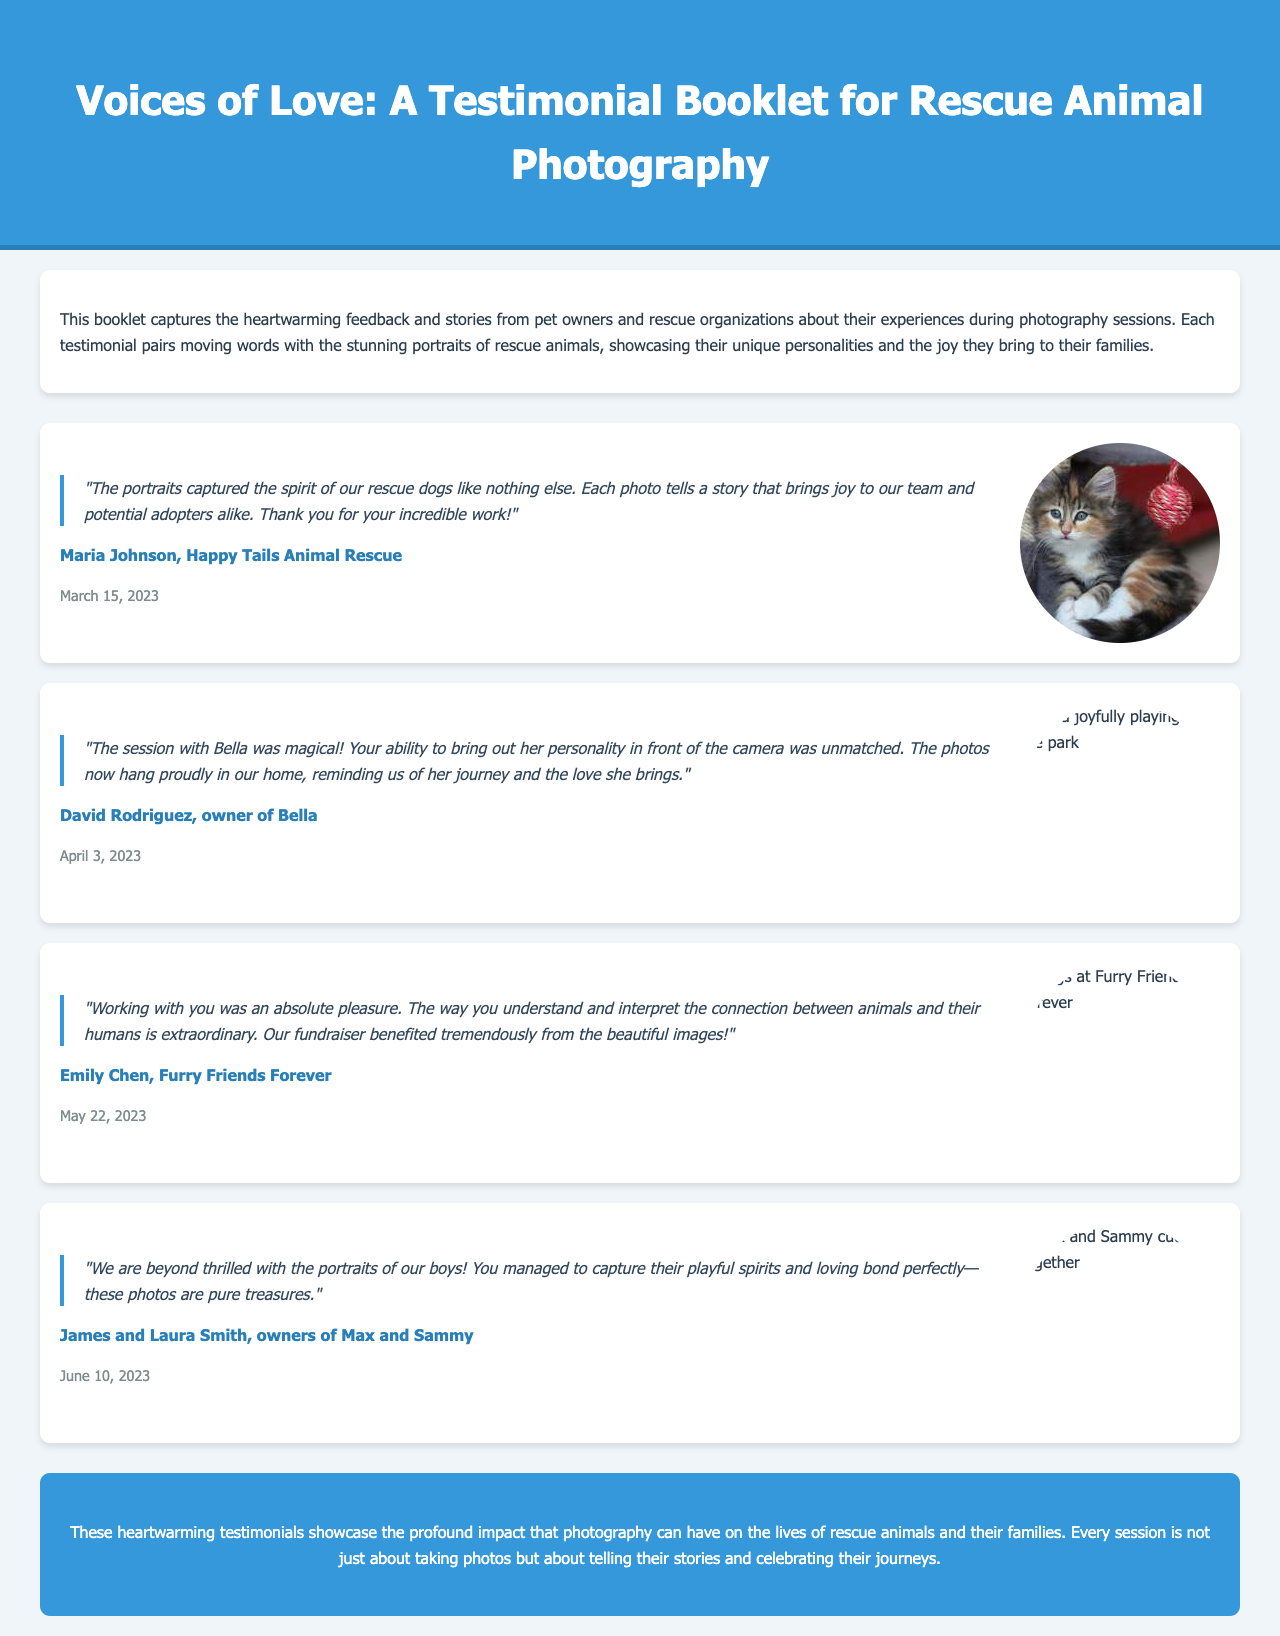What is the title of the booklet? The title of the booklet is found in the header of the document.
Answer: Voices of Love: A Testimonial Booklet for Rescue Animal Photography Who is the author of the first testimonial? The author of the first testimonial is noted in the testimonial section.
Answer: Maria Johnson When was the testimonial by Emily Chen given? The date of Emily Chen's testimonial is included in the testimonial section.
Answer: May 22, 2023 What is the main theme of the testimonials in the booklet? The theme is emphasized in the introductory paragraph.
Answer: Heartwarming feedback and stories How many testimonials are featured in the document? The document contains four distinct testimonials presented in separate sections.
Answer: Four What is the main impact highlighted by the testimonials? The feedback emphasizes the effect of photography on animals and their families, as mentioned in the conclusion.
Answer: Profound impact Which organization is mentioned in David Rodriguez's testimonial? The organization is specified in the testimonial text.
Answer: Bella What styling feature is used to differentiate the quotes? The document uses italics and a border for visual emphasis on quotes.
Answer: Italics and border 